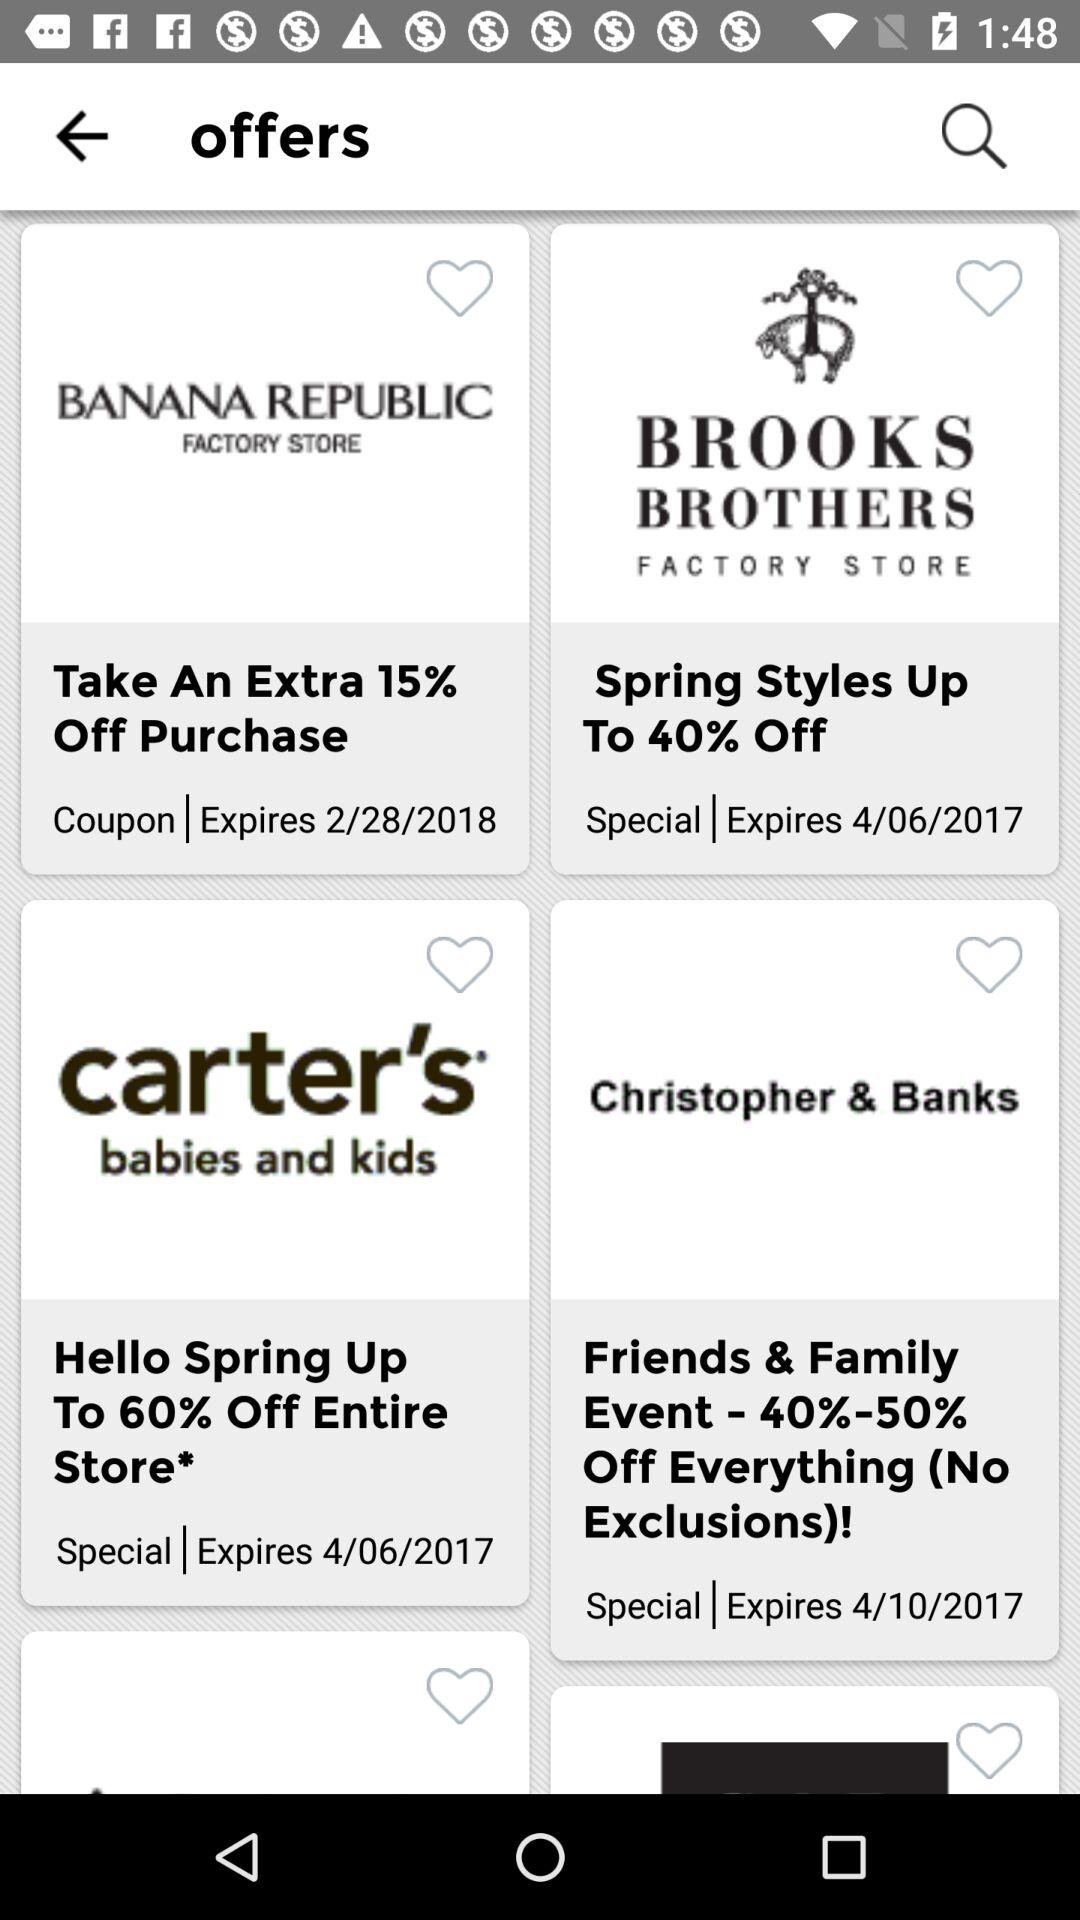Where is the nearest Banana Republic store?
When the provided information is insufficient, respond with <no answer>. <no answer> 